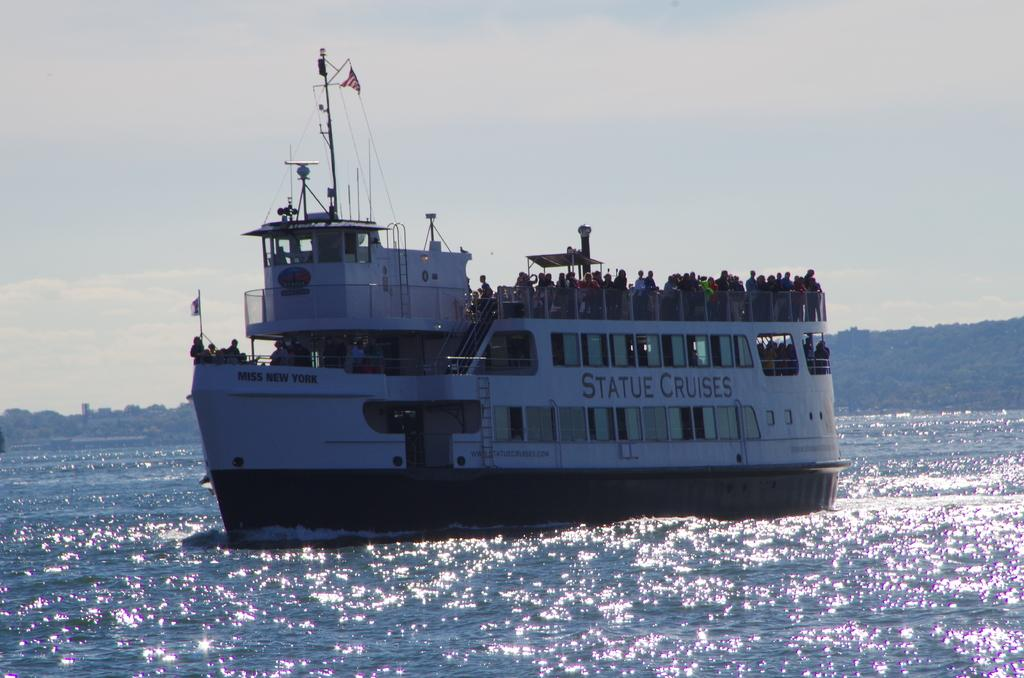What is the main subject of the image? The main subject of the image is a ship. What is the ship doing in the image? The ship is in the water, which suggests it is sailing or floating. Can you describe the people in the image? There are people in the ship, but their specific actions or roles are not clear from the image. What can be seen in the background of the image? In the background of the image, there are mountains, trees, and a sky visible. How many elements are present in the background of the image? There are three elements present in the background: mountains, trees, and the sky. What type of suggestion can be seen written on the side of the ship in the image? There is no suggestion written on the side of the ship in the image; it is a visual representation of a ship in the water. Can you tell me how many snails are crawling on the ship in the image? There are no snails present on the ship in the image. 